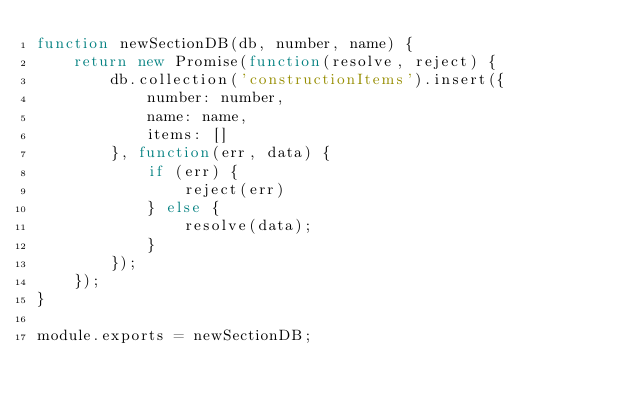<code> <loc_0><loc_0><loc_500><loc_500><_JavaScript_>function newSectionDB(db, number, name) {
    return new Promise(function(resolve, reject) {
        db.collection('constructionItems').insert({
            number: number,
            name: name,
            items: []
        }, function(err, data) {
            if (err) {
                reject(err)
            } else {
                resolve(data);
            }
        });
    });
}

module.exports = newSectionDB;
</code> 